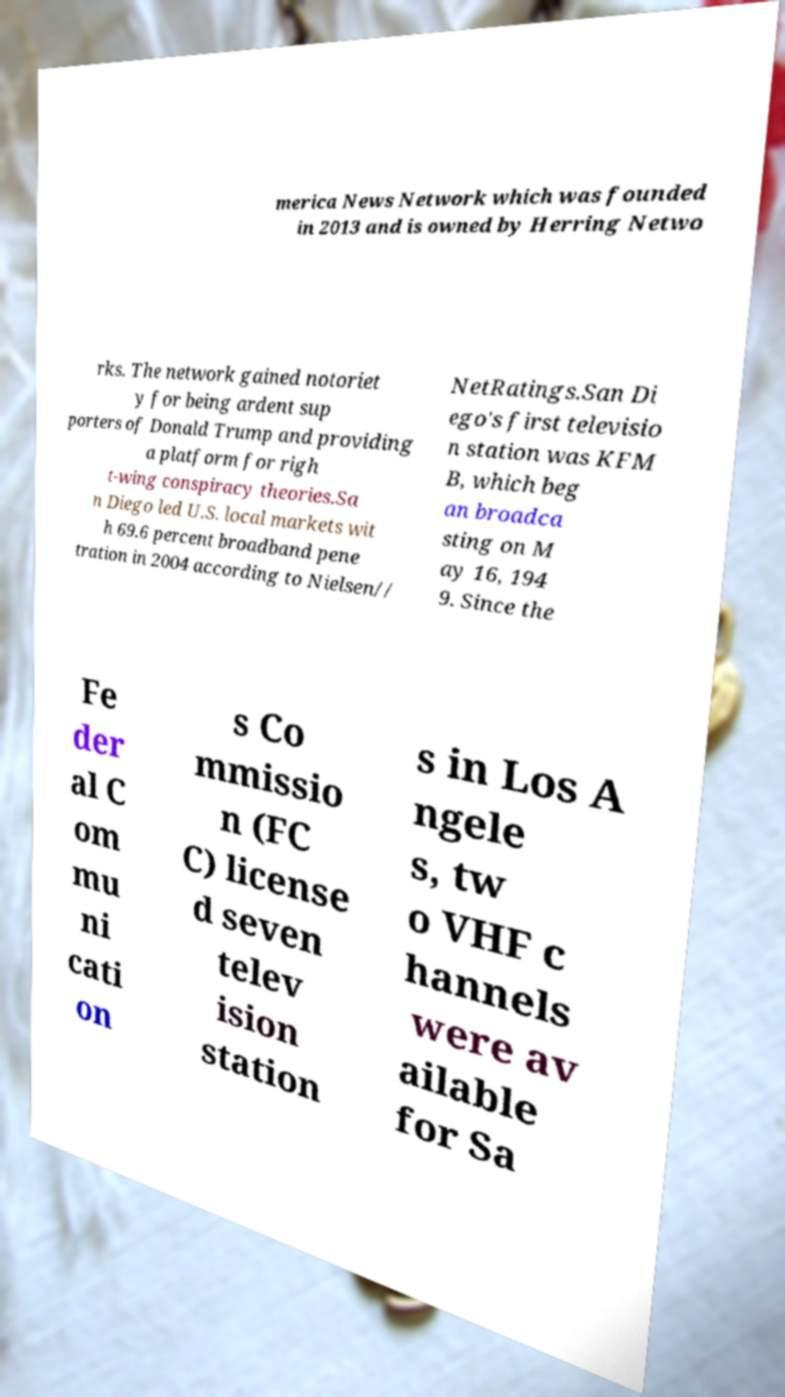Please read and relay the text visible in this image. What does it say? merica News Network which was founded in 2013 and is owned by Herring Netwo rks. The network gained notoriet y for being ardent sup porters of Donald Trump and providing a platform for righ t-wing conspiracy theories.Sa n Diego led U.S. local markets wit h 69.6 percent broadband pene tration in 2004 according to Nielsen// NetRatings.San Di ego's first televisio n station was KFM B, which beg an broadca sting on M ay 16, 194 9. Since the Fe der al C om mu ni cati on s Co mmissio n (FC C) license d seven telev ision station s in Los A ngele s, tw o VHF c hannels were av ailable for Sa 